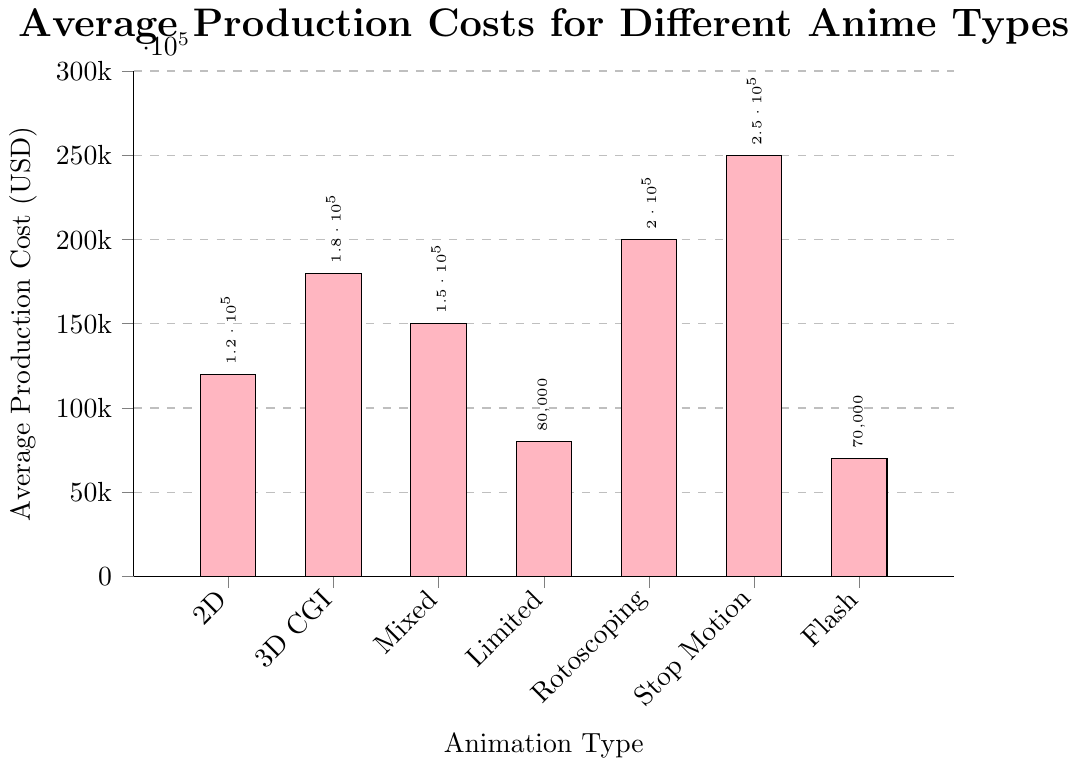Which type of animation has the highest average production cost? By observing the height of the bars, the Stop Motion animation type has the highest bar, indicating it has the highest production cost.
Answer: Stop Motion Compare the average production costs of Flash Animation and Limited Animation types. Which one is more expensive and by how much? To find the difference, subtract Flash Animation's cost ($70,000) from Limited Animation's cost ($80,000).
Answer: Limited Animation, $10,000 What is the average production cost of Mixed Media animation type and 2D Traditional animation type combined? First, add the costs of both types: $150,000 (Mixed Media) + $120,000 (2D Traditional) = $270,000. Then, divide by 2 (number of types) to get the average: $270,000 / 2 = $135,000.
Answer: $135,000 How much more expensive is 3D CGI animation compared to 2D Traditional animation? Subtract the cost of 2D Traditional from 3D CGI: $180,000 - $120,000 = $60,000.
Answer: $60,000 What is the median average production cost among the given animation types? Arrange costs in ascending order: $70,000, $80,000, $120,000, $150,000, $180,000, $200,000, $250,000. The median is the middle value, so here it's $150,000.
Answer: $150,000 Identify the animation type represented by the visually shortest bar. The shortest bar, visually, belongs to Flash Animation with a production cost of $70,000.
Answer: Flash Animation Which is more costly on average: Rotoscoping or Mixed Media animation, and by what percentage is it higher? To find the percentage, first find the price difference: $200,000 (Rotoscoping) - $150,000 (Mixed Media) = $50,000. Then, calculate the percentage: ($50,000 / $150,000) * 100 = ~33.3%.
Answer: Rotoscoping, ~33.3% If the average production cost of Limited Animation increased by 50%, what would the new cost be? Increase $80,000 by 50%: $80,000 + ($80,000 * 0.5) = $80,000 + $40,000 = $120,000.
Answer: $120,000 Compare the sum of the production costs of Flash Animation, 2D Traditional, and Stop Motion to the sum of 3D CGI and Mixed Media. Which sum is higher? Calculate the sums: Flash + 2D + Stop = $70,000 + $120,000 + $250,000 = $440,000. 3D CGI + Mixed = $180,000 + $150,000 = $330,000. So, the sum of Flash + 2D + Stop is higher.
Answer: Flash + 2D + Stop If you were to equally distribute the cost of Stop Motion animation across four new projects, what would each project's budget be? Divide the cost by 4: $250,000 / 4 = $62,500.
Answer: $62,500 